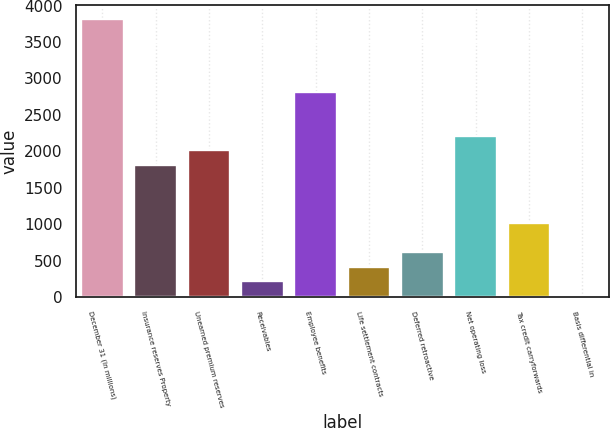Convert chart. <chart><loc_0><loc_0><loc_500><loc_500><bar_chart><fcel>December 31 (In millions)<fcel>Insurance reserves Property<fcel>Unearned premium reserves<fcel>Receivables<fcel>Employee benefits<fcel>Life settlement contracts<fcel>Deferred retroactive<fcel>Net operating loss<fcel>Tax credit carryforwards<fcel>Basis differential in<nl><fcel>3811.4<fcel>1815.4<fcel>2015<fcel>218.6<fcel>2813.4<fcel>418.2<fcel>617.8<fcel>2214.6<fcel>1017<fcel>19<nl></chart> 